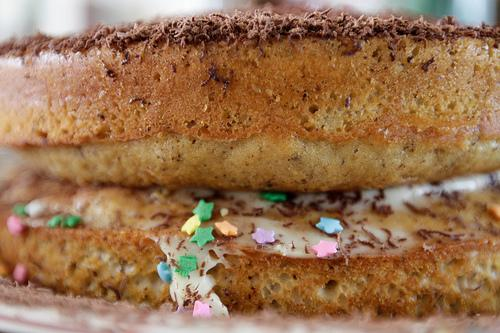Identify the primary food item in the image and its topping. The primary food item is a bread pastry with colorful star-shaped sprinkles on it. Can you spot any star-shaped sprinkles that have a unique hue? No, all the star-shaped sprinkles have common colors: green, yellow, orange, blue, and pink. Assess the quality of the image in terms of clarity and composition. The image has a clear quality and well-organized composition, with the bread pastry and star-shaped sprinkles being easily discernible. What is the sentiment portrayed by the image? The image portrays a cheerful and festive sentiment due to the colorful star-shaped sprinkles on the bread pastry. What type of task involves identifying the individual components and their coordinates in an image? Object detection task involves identifying the components and their coordinates in an image. Describe the chocolate shavings on pancake in the image. There are no chocolate shavings on the pancake; the image features a bread pastry with star-shaped sprinkles. Count the number of small green star sprinkles in the image. There are 6 small green star sprinkles in the image. What is the main object in the image, and how is it decorated? The main object in the image is a bread pastry, and it is decorated with colorful star-shaped sprinkles. What colors are the star-shaped sprinkles in the image? The star-shaped sprinkles are green, yellow, orange, blue, and pink. How many star-shaped sprinkles are there in the image? There are at least 31 star-shaped sprinkles in the image. What event might have transpired explaining the distribution of the star sprinkles? A joyful celebration with a sprinkle toss onto the bread. Which emotion does the arrangement of the star-shaped sprinkles convey? Happiness or joy Provide a poetic description of the image. A canvas of delicious bread graced by lovely celestial confetti, sprinkles of green, yellow, orange, and blue stars dance in beautiful harmony. What are the sizes of the largest and smallest blue star-shaped sprinkles? The largest is 47x47 and the smallest is 16x16. What is the predominant color of the star sprinkles? Green, yellow, and orange How many small green star sprinkles are there on the bread? Six What is the relationship between the star sprinkles and the bread? The star sprinkles are used as a colorful decoration for the bread. What would it look like if the star-shaped sprinkles came to life and began to jump around the bread? A lively scene of colorful, animated star sprinkles happily hopping on the bread's surface, creating a dynamic and energized atmosphere. Explain the layout of the image with a focus on the star-shaped sprinkles. The image shows a bread surface adorned with various sizes and colorful star-shaped sprinkles scattered in a seemingly random yet delightful manner. The small pink star sprinkle is engaged in a competition with other sprinkles. Rank them based on their size, starting from the largest. 1. small blue star sprinkle, 2. small pink star sprinkle, 3. small green star sprinkle, 4. the yellow star shaped sprinkle, 5. the orange star shaped sprinkle, 6. the purple star shaped sprinkle, 7. the pink star shaped sprinkle Can you find a red star-shaped sprinkle in the image? There are no red star-shaped sprinkles mentioned in the given image. All available star-shaped sprinkles are green, yellow, orange, blue, and pink. What narrative can be derived from the placement of the star-shaped sprinkles? A story of a whimsical party where the star-shaped sprinkles, each with their vibrant colors, come together in harmony to create a joyful atmosphere upon the bread surface. Identify the star-shaped sprinkle colors and place them within a playful sentence. The playful pink, beautiful blue, lovely green, outstanding orange, and cheerful yellow star-shaped sprinkles dazzle the bread's surface. Can you spot a square-shaped object with X:200 and Y:200 coordinates in the image? There are no square-shaped objects mentioned in the given image; all objects are sprinkles, bread pastries or chocolate shavings, none of which have a square shape. Is there a green star shaped sprinkle with X:250 and Y:250 coordinates? There is no green star-shaped sprinkle with X:250 and Y:250 coordinates in the given image. All the mentioned green star sprinkles have different coordinates. Can you find a chocolate shaving with X:100, Y:100, Width:50, and Height:50 in the image? There is no chocolate shaving with these specific coordinates and sizes. All mentioned chocolate shavings in the given image have different sizes and coordinates. Describe the arrangement of star-shaped sprinkles in the form of an uplifting limerick. Upon a bread so soft and true, star sprinkles danced and gleefully flew. With colors so bright, they lit up the night, spreading joy in their whimsical hue. Is there a bread pastry with X:400 and Y:400 coordinates and Width:100 and Height:100? There is no bread pastry with these specific coordinates and sizes. All mentioned bread pastries or similar objects have different sizes and coordinates. Is there a purple star-shaped sprinkle with X:180 and Y:214 coordinates? There is no purple star-shaped sprinkle with X:180 and Y:214 coordinates. The only purple star-shaped sprinkle has X:251 and Y:227 coordinates. Which color of star-shaped sprinkle is closest to the top-left corner of the image? Pink 